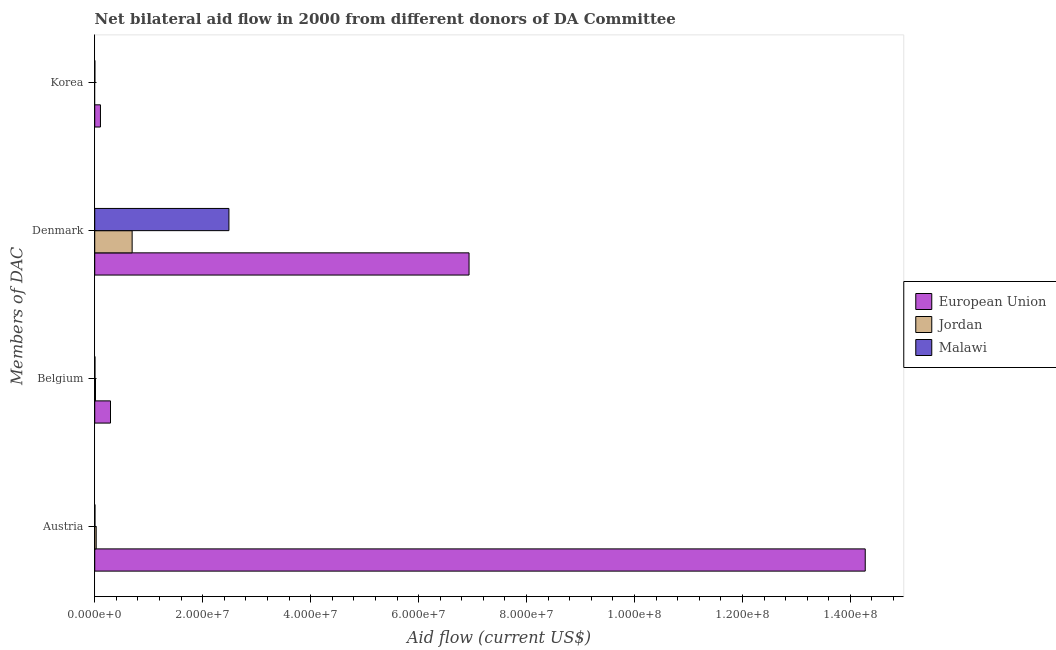Are the number of bars per tick equal to the number of legend labels?
Your answer should be very brief. No. Are the number of bars on each tick of the Y-axis equal?
Your answer should be compact. No. How many bars are there on the 1st tick from the top?
Provide a short and direct response. 2. What is the label of the 1st group of bars from the top?
Your response must be concise. Korea. What is the amount of aid given by denmark in Malawi?
Your answer should be compact. 2.49e+07. Across all countries, what is the maximum amount of aid given by belgium?
Ensure brevity in your answer.  2.92e+06. Across all countries, what is the minimum amount of aid given by korea?
Your answer should be compact. 0. What is the total amount of aid given by korea in the graph?
Provide a short and direct response. 1.08e+06. What is the difference between the amount of aid given by belgium in Malawi and that in European Union?
Your response must be concise. -2.88e+06. What is the difference between the amount of aid given by austria in European Union and the amount of aid given by belgium in Malawi?
Make the answer very short. 1.43e+08. What is the average amount of aid given by belgium per country?
Provide a short and direct response. 1.03e+06. What is the difference between the amount of aid given by denmark and amount of aid given by austria in European Union?
Provide a short and direct response. -7.34e+07. In how many countries, is the amount of aid given by belgium greater than 136000000 US$?
Give a very brief answer. 0. What is the ratio of the amount of aid given by korea in Malawi to that in European Union?
Your response must be concise. 0.02. Is the amount of aid given by austria in Jordan less than that in Malawi?
Offer a terse response. No. What is the difference between the highest and the second highest amount of aid given by denmark?
Make the answer very short. 4.45e+07. What is the difference between the highest and the lowest amount of aid given by korea?
Ensure brevity in your answer.  1.06e+06. In how many countries, is the amount of aid given by austria greater than the average amount of aid given by austria taken over all countries?
Give a very brief answer. 1. Are the values on the major ticks of X-axis written in scientific E-notation?
Your response must be concise. Yes. Does the graph contain grids?
Your answer should be very brief. No. How many legend labels are there?
Your response must be concise. 3. What is the title of the graph?
Provide a short and direct response. Net bilateral aid flow in 2000 from different donors of DA Committee. What is the label or title of the X-axis?
Make the answer very short. Aid flow (current US$). What is the label or title of the Y-axis?
Your answer should be compact. Members of DAC. What is the Aid flow (current US$) of European Union in Austria?
Provide a succinct answer. 1.43e+08. What is the Aid flow (current US$) of European Union in Belgium?
Provide a short and direct response. 2.92e+06. What is the Aid flow (current US$) of Jordan in Belgium?
Your answer should be very brief. 1.40e+05. What is the Aid flow (current US$) of Malawi in Belgium?
Your response must be concise. 4.00e+04. What is the Aid flow (current US$) of European Union in Denmark?
Offer a very short reply. 6.94e+07. What is the Aid flow (current US$) in Jordan in Denmark?
Make the answer very short. 6.93e+06. What is the Aid flow (current US$) in Malawi in Denmark?
Provide a short and direct response. 2.49e+07. What is the Aid flow (current US$) in European Union in Korea?
Provide a short and direct response. 1.06e+06. What is the Aid flow (current US$) of Jordan in Korea?
Give a very brief answer. 0. What is the Aid flow (current US$) in Malawi in Korea?
Give a very brief answer. 2.00e+04. Across all Members of DAC, what is the maximum Aid flow (current US$) of European Union?
Provide a short and direct response. 1.43e+08. Across all Members of DAC, what is the maximum Aid flow (current US$) in Jordan?
Keep it short and to the point. 6.93e+06. Across all Members of DAC, what is the maximum Aid flow (current US$) in Malawi?
Provide a succinct answer. 2.49e+07. Across all Members of DAC, what is the minimum Aid flow (current US$) in European Union?
Ensure brevity in your answer.  1.06e+06. What is the total Aid flow (current US$) in European Union in the graph?
Your answer should be compact. 2.16e+08. What is the total Aid flow (current US$) of Jordan in the graph?
Provide a short and direct response. 7.34e+06. What is the total Aid flow (current US$) in Malawi in the graph?
Your answer should be compact. 2.50e+07. What is the difference between the Aid flow (current US$) of European Union in Austria and that in Belgium?
Your response must be concise. 1.40e+08. What is the difference between the Aid flow (current US$) in Jordan in Austria and that in Belgium?
Keep it short and to the point. 1.30e+05. What is the difference between the Aid flow (current US$) in Malawi in Austria and that in Belgium?
Provide a succinct answer. 0. What is the difference between the Aid flow (current US$) in European Union in Austria and that in Denmark?
Make the answer very short. 7.34e+07. What is the difference between the Aid flow (current US$) of Jordan in Austria and that in Denmark?
Make the answer very short. -6.66e+06. What is the difference between the Aid flow (current US$) in Malawi in Austria and that in Denmark?
Provide a succinct answer. -2.48e+07. What is the difference between the Aid flow (current US$) in European Union in Austria and that in Korea?
Your response must be concise. 1.42e+08. What is the difference between the Aid flow (current US$) of European Union in Belgium and that in Denmark?
Your answer should be very brief. -6.64e+07. What is the difference between the Aid flow (current US$) in Jordan in Belgium and that in Denmark?
Provide a succinct answer. -6.79e+06. What is the difference between the Aid flow (current US$) in Malawi in Belgium and that in Denmark?
Your response must be concise. -2.48e+07. What is the difference between the Aid flow (current US$) in European Union in Belgium and that in Korea?
Your response must be concise. 1.86e+06. What is the difference between the Aid flow (current US$) in Malawi in Belgium and that in Korea?
Your answer should be very brief. 2.00e+04. What is the difference between the Aid flow (current US$) of European Union in Denmark and that in Korea?
Provide a short and direct response. 6.83e+07. What is the difference between the Aid flow (current US$) of Malawi in Denmark and that in Korea?
Offer a very short reply. 2.48e+07. What is the difference between the Aid flow (current US$) in European Union in Austria and the Aid flow (current US$) in Jordan in Belgium?
Provide a succinct answer. 1.43e+08. What is the difference between the Aid flow (current US$) of European Union in Austria and the Aid flow (current US$) of Malawi in Belgium?
Provide a succinct answer. 1.43e+08. What is the difference between the Aid flow (current US$) of European Union in Austria and the Aid flow (current US$) of Jordan in Denmark?
Your answer should be compact. 1.36e+08. What is the difference between the Aid flow (current US$) in European Union in Austria and the Aid flow (current US$) in Malawi in Denmark?
Your response must be concise. 1.18e+08. What is the difference between the Aid flow (current US$) in Jordan in Austria and the Aid flow (current US$) in Malawi in Denmark?
Your response must be concise. -2.46e+07. What is the difference between the Aid flow (current US$) in European Union in Austria and the Aid flow (current US$) in Malawi in Korea?
Keep it short and to the point. 1.43e+08. What is the difference between the Aid flow (current US$) of Jordan in Austria and the Aid flow (current US$) of Malawi in Korea?
Provide a short and direct response. 2.50e+05. What is the difference between the Aid flow (current US$) of European Union in Belgium and the Aid flow (current US$) of Jordan in Denmark?
Your answer should be very brief. -4.01e+06. What is the difference between the Aid flow (current US$) of European Union in Belgium and the Aid flow (current US$) of Malawi in Denmark?
Offer a very short reply. -2.19e+07. What is the difference between the Aid flow (current US$) of Jordan in Belgium and the Aid flow (current US$) of Malawi in Denmark?
Offer a very short reply. -2.47e+07. What is the difference between the Aid flow (current US$) of European Union in Belgium and the Aid flow (current US$) of Malawi in Korea?
Offer a terse response. 2.90e+06. What is the difference between the Aid flow (current US$) in Jordan in Belgium and the Aid flow (current US$) in Malawi in Korea?
Offer a terse response. 1.20e+05. What is the difference between the Aid flow (current US$) in European Union in Denmark and the Aid flow (current US$) in Malawi in Korea?
Ensure brevity in your answer.  6.93e+07. What is the difference between the Aid flow (current US$) of Jordan in Denmark and the Aid flow (current US$) of Malawi in Korea?
Make the answer very short. 6.91e+06. What is the average Aid flow (current US$) of European Union per Members of DAC?
Your answer should be very brief. 5.40e+07. What is the average Aid flow (current US$) in Jordan per Members of DAC?
Offer a terse response. 1.84e+06. What is the average Aid flow (current US$) in Malawi per Members of DAC?
Offer a terse response. 6.24e+06. What is the difference between the Aid flow (current US$) of European Union and Aid flow (current US$) of Jordan in Austria?
Provide a succinct answer. 1.42e+08. What is the difference between the Aid flow (current US$) of European Union and Aid flow (current US$) of Malawi in Austria?
Keep it short and to the point. 1.43e+08. What is the difference between the Aid flow (current US$) of European Union and Aid flow (current US$) of Jordan in Belgium?
Offer a very short reply. 2.78e+06. What is the difference between the Aid flow (current US$) in European Union and Aid flow (current US$) in Malawi in Belgium?
Your answer should be very brief. 2.88e+06. What is the difference between the Aid flow (current US$) of European Union and Aid flow (current US$) of Jordan in Denmark?
Give a very brief answer. 6.24e+07. What is the difference between the Aid flow (current US$) in European Union and Aid flow (current US$) in Malawi in Denmark?
Keep it short and to the point. 4.45e+07. What is the difference between the Aid flow (current US$) of Jordan and Aid flow (current US$) of Malawi in Denmark?
Provide a succinct answer. -1.79e+07. What is the difference between the Aid flow (current US$) of European Union and Aid flow (current US$) of Malawi in Korea?
Your answer should be very brief. 1.04e+06. What is the ratio of the Aid flow (current US$) of European Union in Austria to that in Belgium?
Your response must be concise. 48.89. What is the ratio of the Aid flow (current US$) in Jordan in Austria to that in Belgium?
Your answer should be very brief. 1.93. What is the ratio of the Aid flow (current US$) in European Union in Austria to that in Denmark?
Make the answer very short. 2.06. What is the ratio of the Aid flow (current US$) of Jordan in Austria to that in Denmark?
Your response must be concise. 0.04. What is the ratio of the Aid flow (current US$) in Malawi in Austria to that in Denmark?
Provide a succinct answer. 0. What is the ratio of the Aid flow (current US$) of European Union in Austria to that in Korea?
Keep it short and to the point. 134.67. What is the ratio of the Aid flow (current US$) in Malawi in Austria to that in Korea?
Offer a terse response. 2. What is the ratio of the Aid flow (current US$) of European Union in Belgium to that in Denmark?
Your answer should be compact. 0.04. What is the ratio of the Aid flow (current US$) of Jordan in Belgium to that in Denmark?
Offer a terse response. 0.02. What is the ratio of the Aid flow (current US$) of Malawi in Belgium to that in Denmark?
Offer a terse response. 0. What is the ratio of the Aid flow (current US$) of European Union in Belgium to that in Korea?
Provide a succinct answer. 2.75. What is the ratio of the Aid flow (current US$) in European Union in Denmark to that in Korea?
Offer a very short reply. 65.42. What is the ratio of the Aid flow (current US$) of Malawi in Denmark to that in Korea?
Offer a very short reply. 1243. What is the difference between the highest and the second highest Aid flow (current US$) in European Union?
Provide a succinct answer. 7.34e+07. What is the difference between the highest and the second highest Aid flow (current US$) in Jordan?
Offer a very short reply. 6.66e+06. What is the difference between the highest and the second highest Aid flow (current US$) in Malawi?
Ensure brevity in your answer.  2.48e+07. What is the difference between the highest and the lowest Aid flow (current US$) of European Union?
Your response must be concise. 1.42e+08. What is the difference between the highest and the lowest Aid flow (current US$) of Jordan?
Make the answer very short. 6.93e+06. What is the difference between the highest and the lowest Aid flow (current US$) of Malawi?
Offer a terse response. 2.48e+07. 